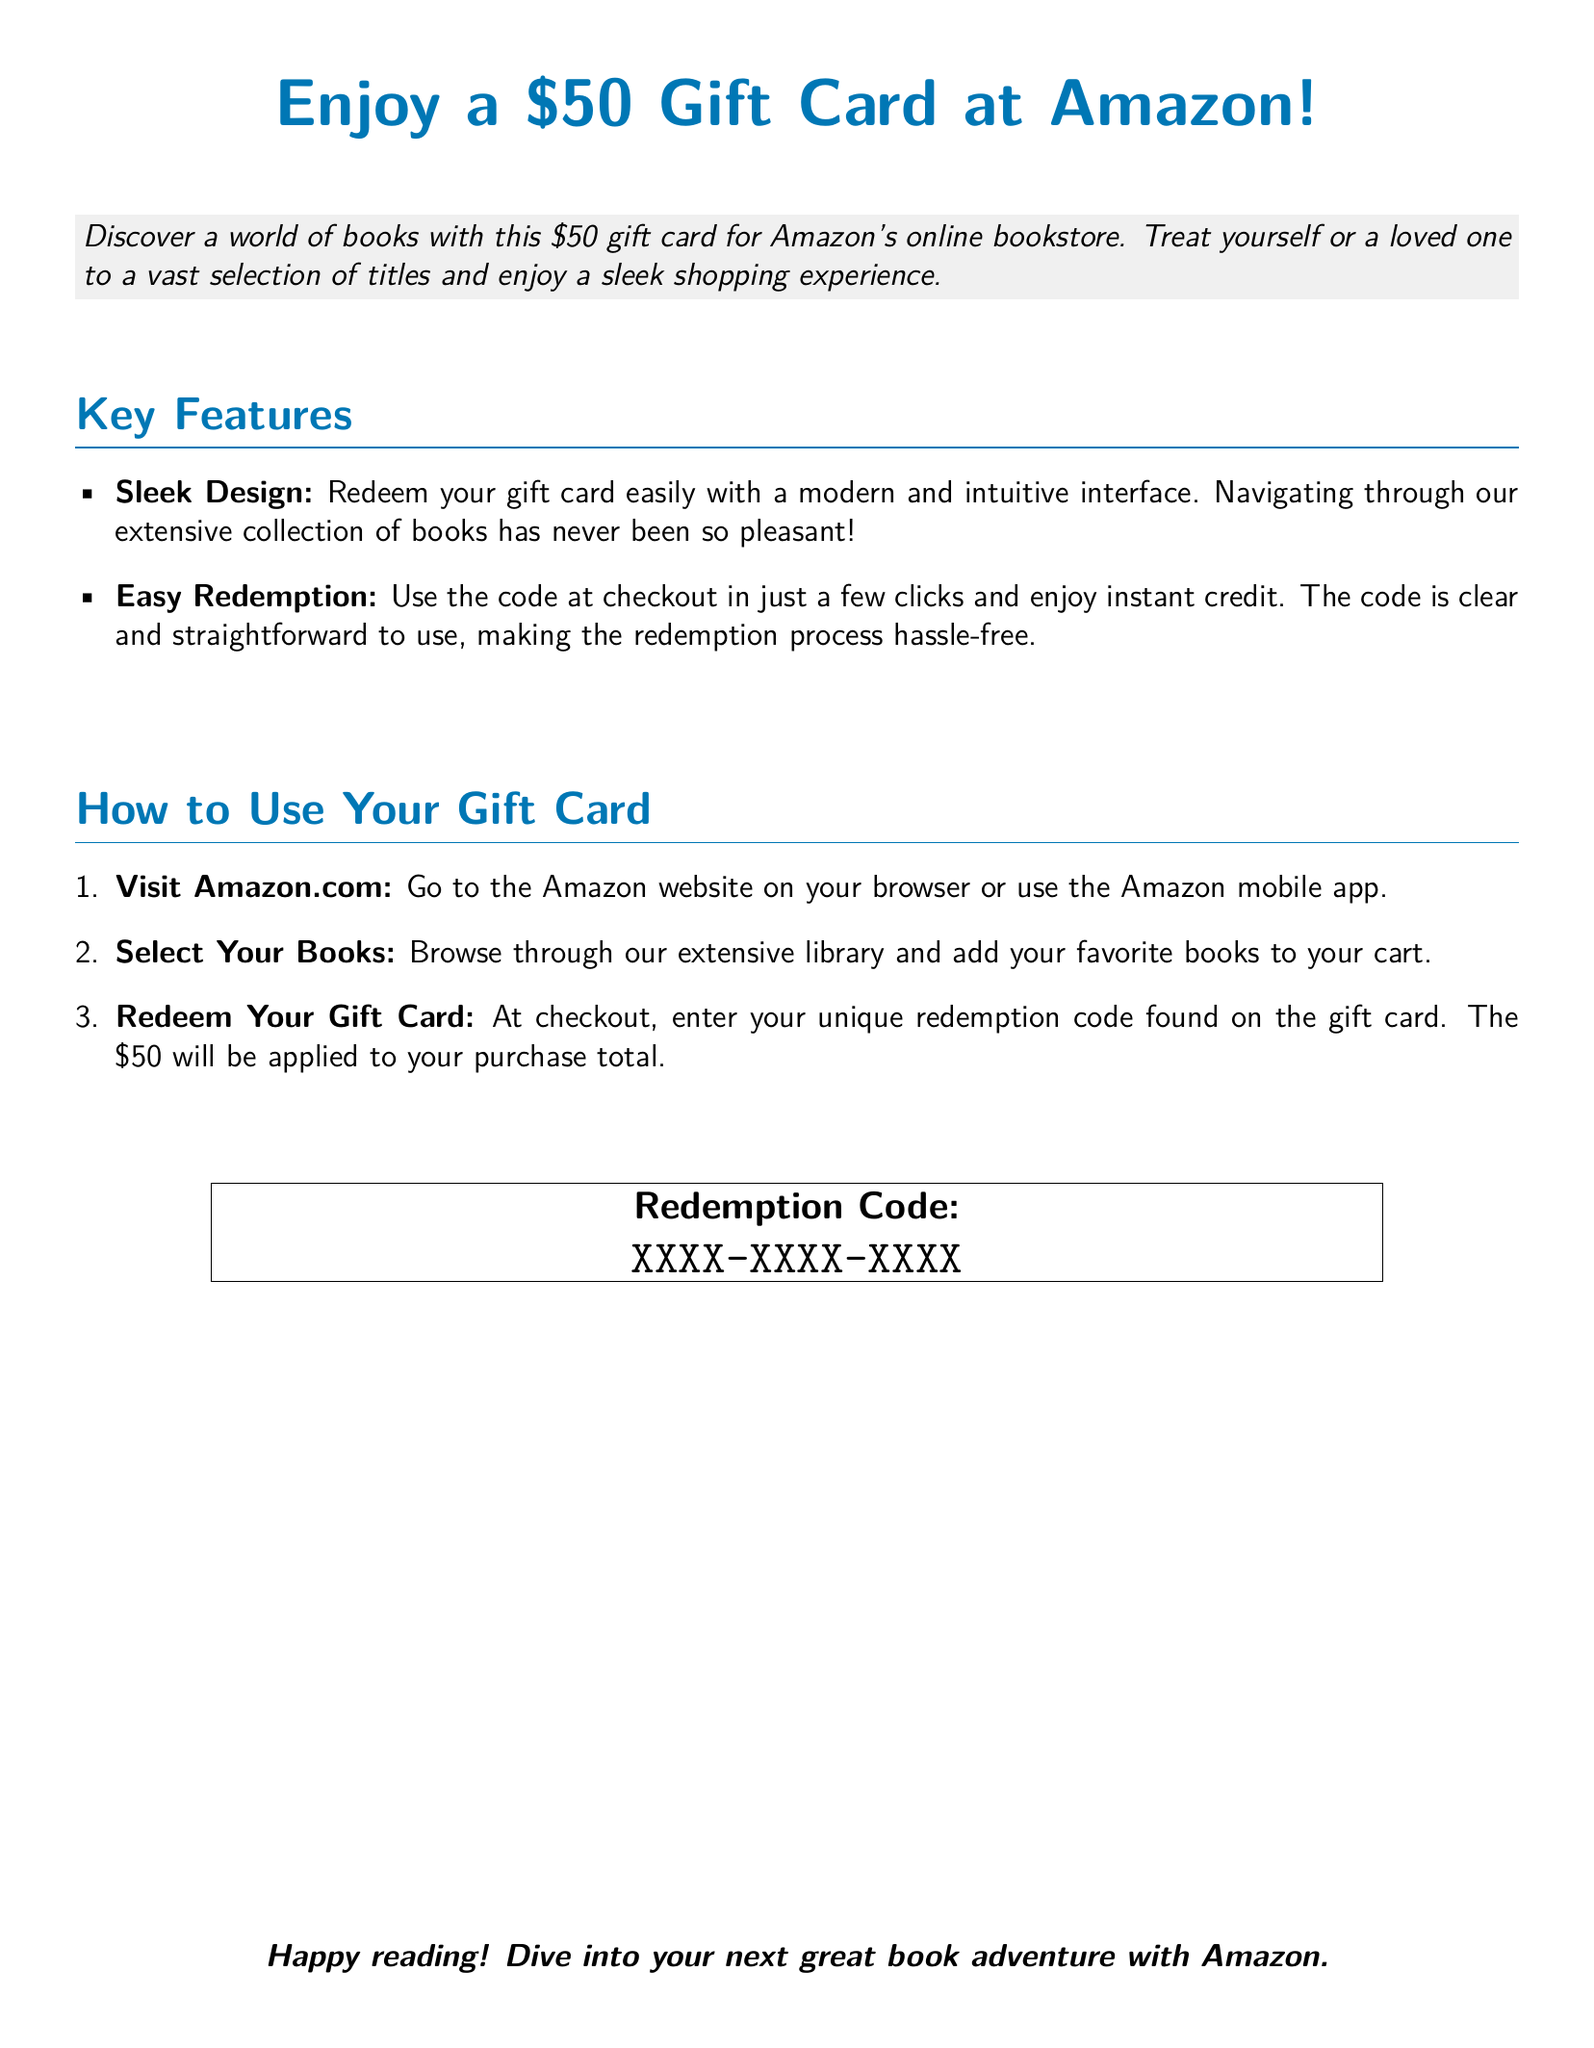What is the value of the gift card? The document specifies that the gift card is valued at $50.
Answer: $50 What online platform can you redeem the gift card on? The document mentions that the gift card can be redeemed on Amazon.com.
Answer: Amazon.com What must you enter at checkout to use the gift card? The document states that you need to enter a unique redemption code at checkout.
Answer: unique redemption code How many steps are listed for using the gift card? The document outlines three specific steps to redeem the gift card.
Answer: three What color represents the title in the document? The title is highlighted in the color specified as amazonblue.
Answer: amazonblue What is mentioned as a feature of the gift card design? The gift card features a sleek and modern design for easy navigation.
Answer: sleek design What do you do after selecting your books? After selecting your books, you are instructed to redeem your gift card at checkout.
Answer: redeem your gift card What does the document encourage you to do at the end? The document encourages you to dive into your next great book adventure.
Answer: dive into your next great book adventure 